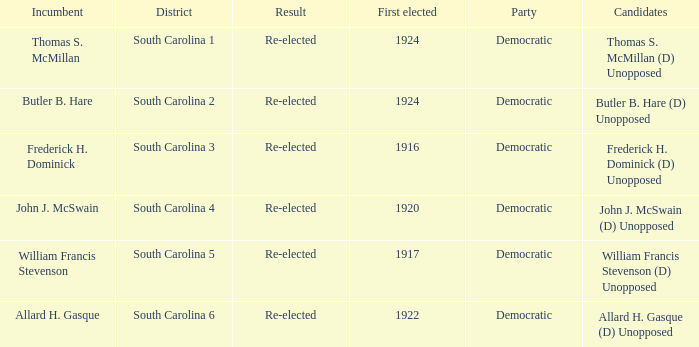What is the result for south carolina 4? Re-elected. 